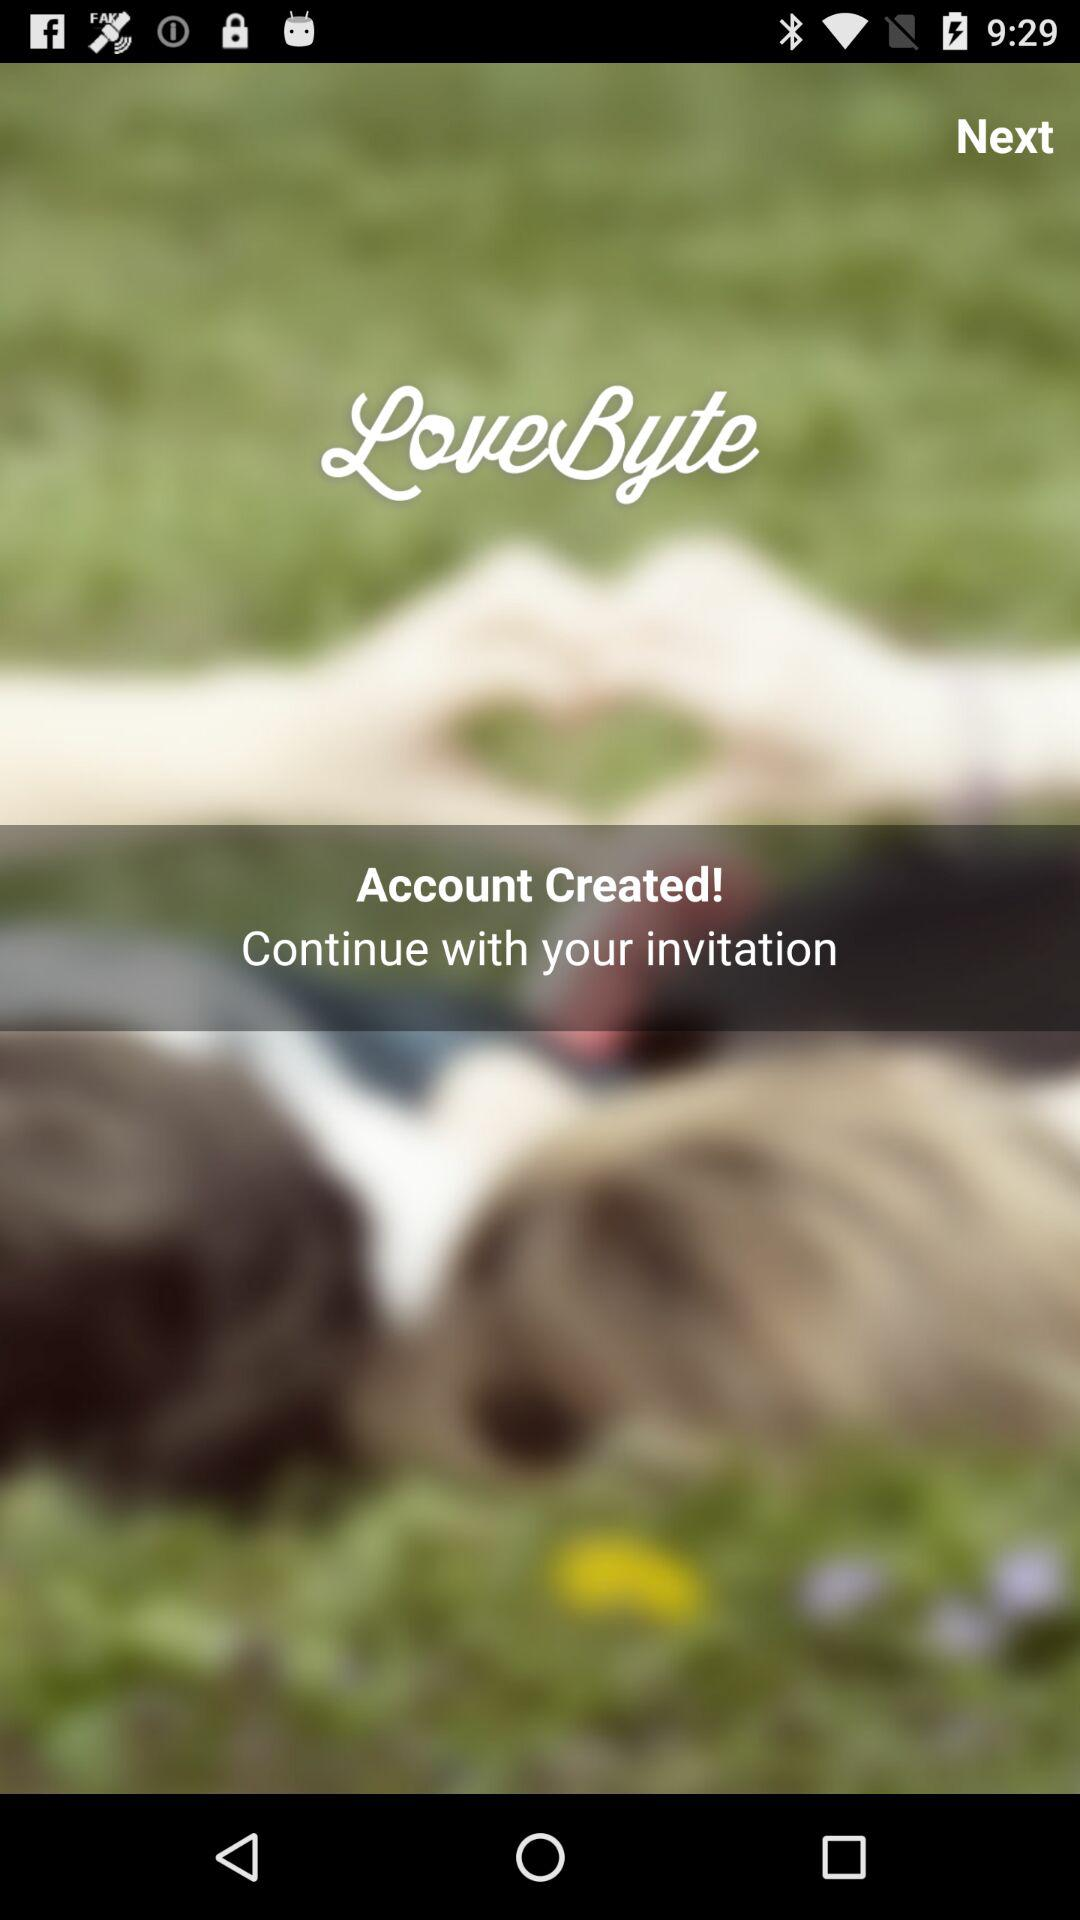Which gender did the user select?
When the provided information is insufficient, respond with <no answer>. <no answer> 